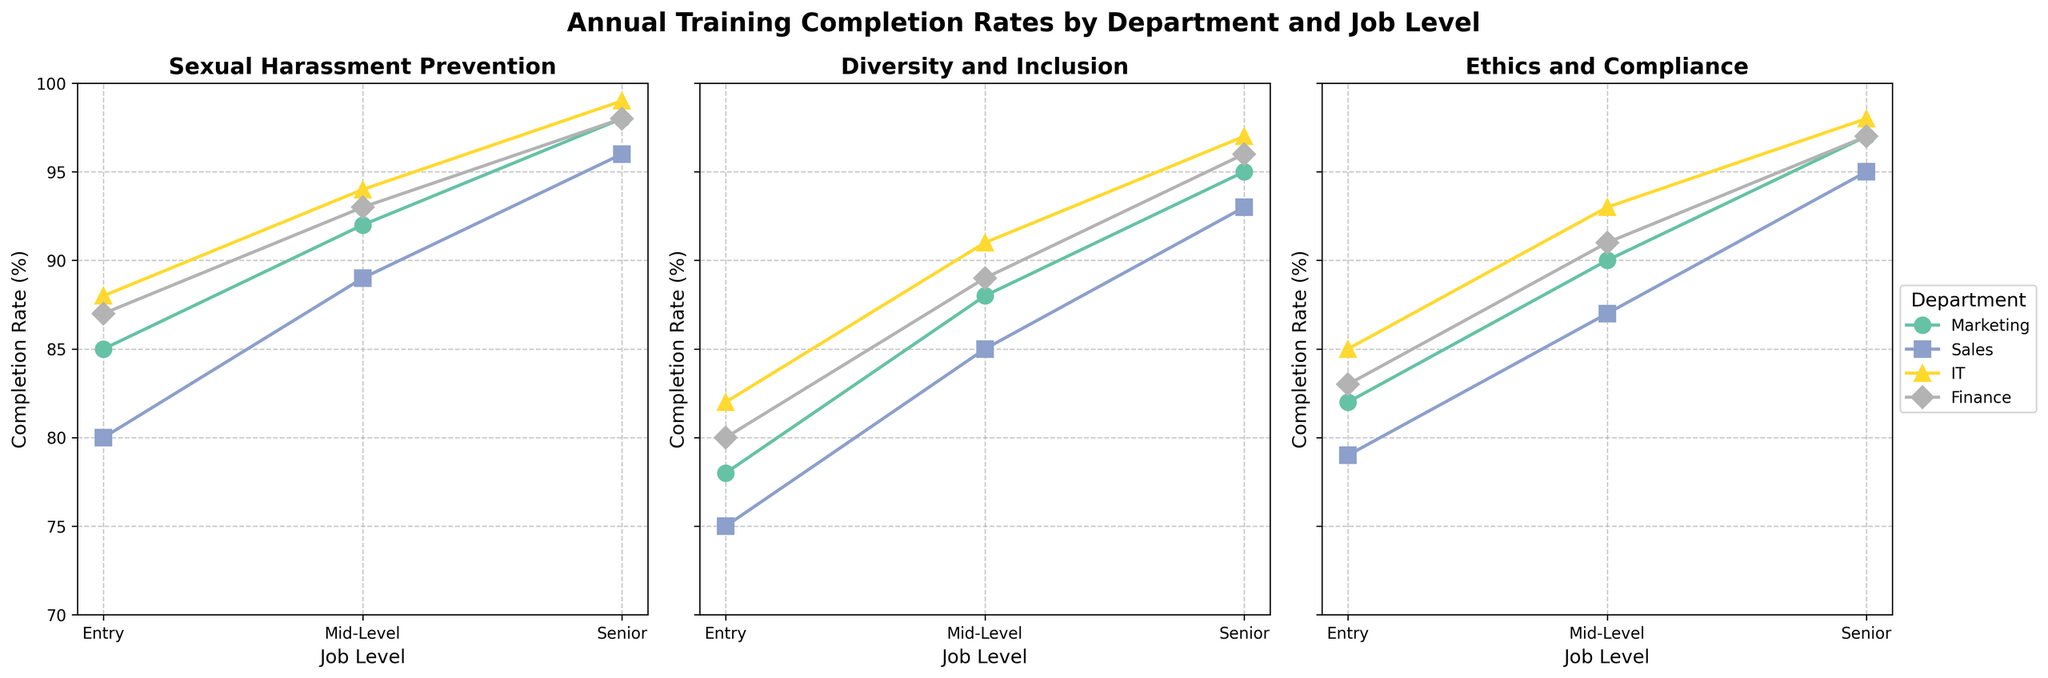What is the entry-level completion rate for the Sexual Harassment Prevention course in the IT department? Locate the subplot titled "Sexual Harassment Prevention." Then, identify the line and data point specific to the IT department. Follow the entry-level marker to find the corresponding completion rate.
Answer: 88 Which department has the highest completion rate for the Diversity and Inclusion course at the senior job level? Locate the subplot titled "Diversity and Inclusion." Compare the senior job level markers across all department lines. Identify the highest completion rate.
Answer: IT Compare the mid-level completion rates between the Marketing and Sales departments for the Ethics and Compliance course. Which is higher, and by how much? Locate the subplot titled "Ethics and Compliance." Identify the mid-level markers for both Marketing and Sales lines. Subtract the Sales completion rate from the Marketing completion rate.
Answer: Marketing by 3% What is the average completion rate of the senior-level job for the Diversity and Inclusion course across all departments? Locate the subplot titled "Diversity and Inclusion." Identify the senior-level markers for all departments. Add the completion rates for all the departments and divide by the number of departments (4).
Answer: 95.25 For the Sexual Harassment Prevention course, which department shows the greatest increase in completion rate from entry-level to senior-level? Locate the subplot titled "Sexual Harassment Prevention." Calculate the difference in completion rates between entry-level and senior-level for each department. Identify the department with the highest increase.
Answer: Sales How does the entry-level completion rate for the Ethics and Compliance course in Marketing compare to the entry-level completion rate in Finance? Locate the subplot titled "Ethics and Compliance." Compare the entry-level markers for both Marketing and Finance lines.
Answer: Marketing is lower by 1% Which job level and department combination has the lowest completion rate for the Diversity and Inclusion course? Locate the subplot titled "Diversity and Inclusion." Identify the lowest marker across all job levels and departments.
Answer: Sales Entry Does the Finance department have the same senior-level completion rate for all courses? Observe the senior-level markers for the Finance department across all subplots. Check if the values are identical.
Answer: No What is the median completion rate for the mid-level job in the Sexual Harassment Prevention course across all departments? Locate the subplot titled "Sexual Harassment Prevention." Identify the mid-level markers for all departments. Arrange these rates in ascending order and find the median value.
Answer: 93 Is the senior-level completion rate for the Ethics and Compliance course higher in IT or Sales? Locate the subplot titled "Ethics and Compliance." Compare the senior-level markers for IT and Sales. Identify which is higher.
Answer: IT 